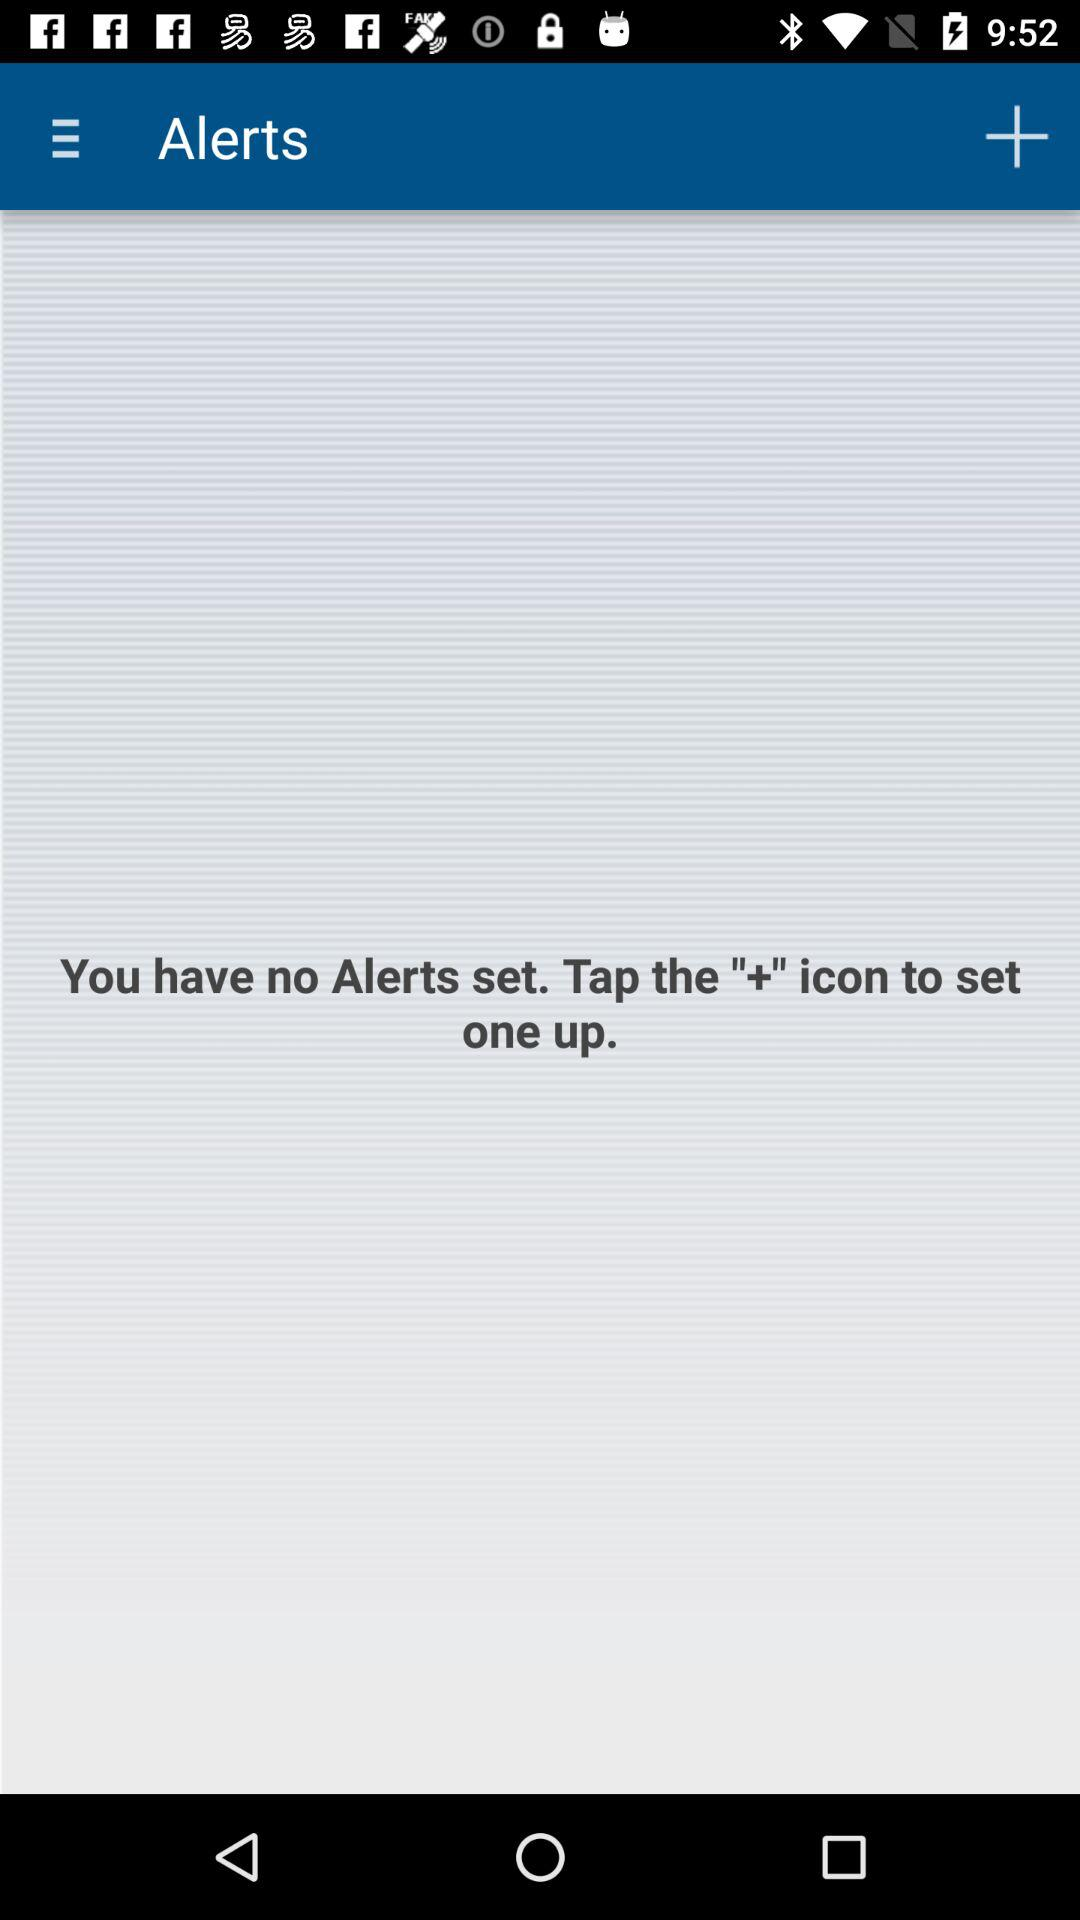Is there any alert set? There is no alert set. 